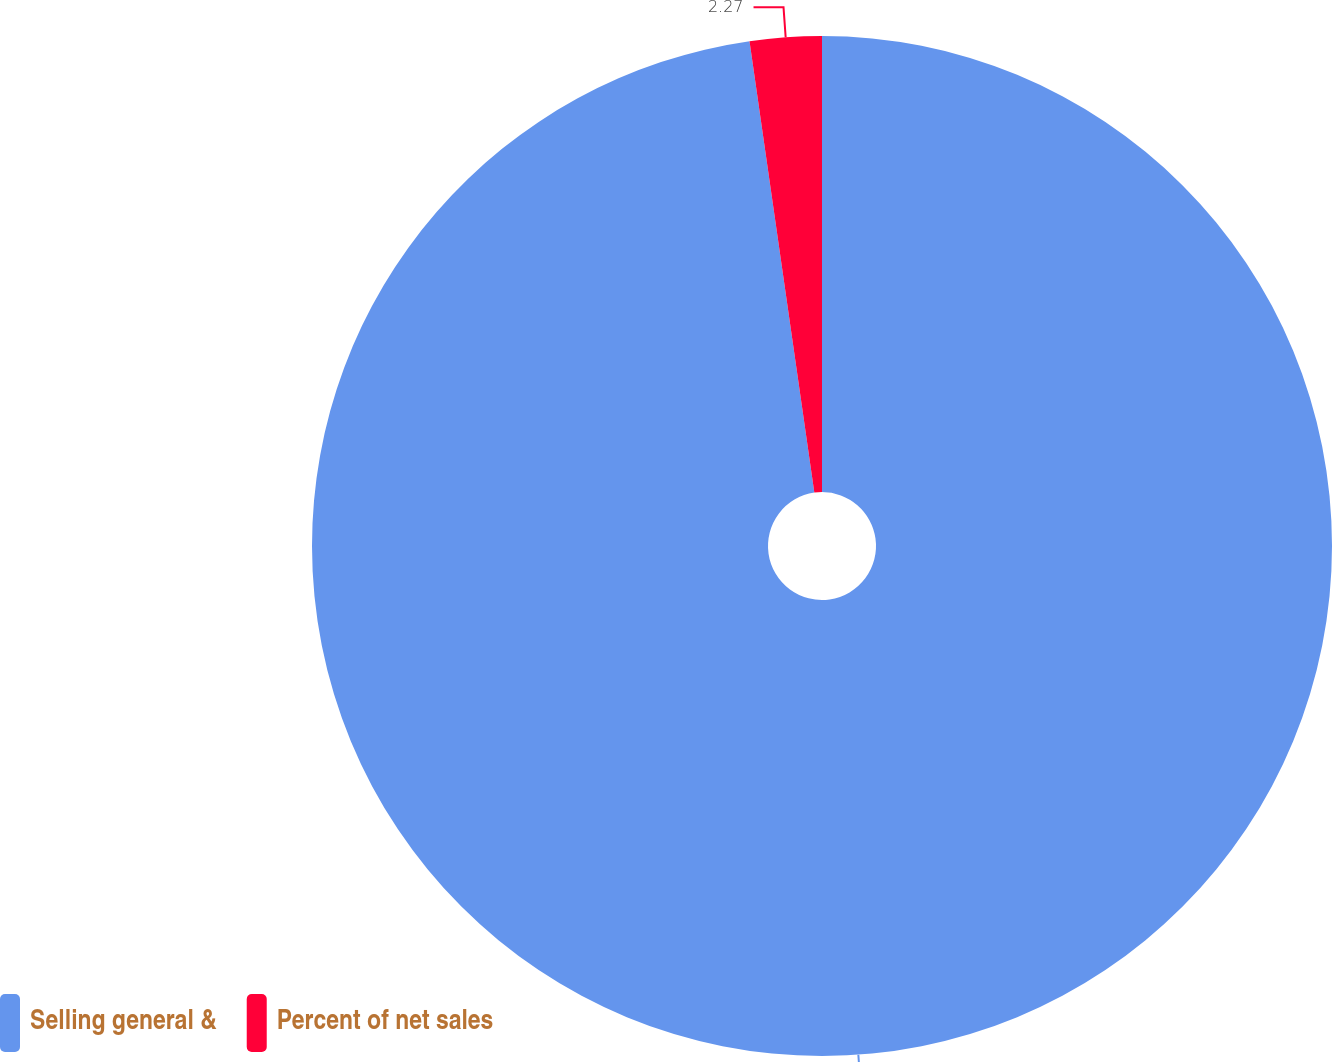<chart> <loc_0><loc_0><loc_500><loc_500><pie_chart><fcel>Selling general &<fcel>Percent of net sales<nl><fcel>97.73%<fcel>2.27%<nl></chart> 